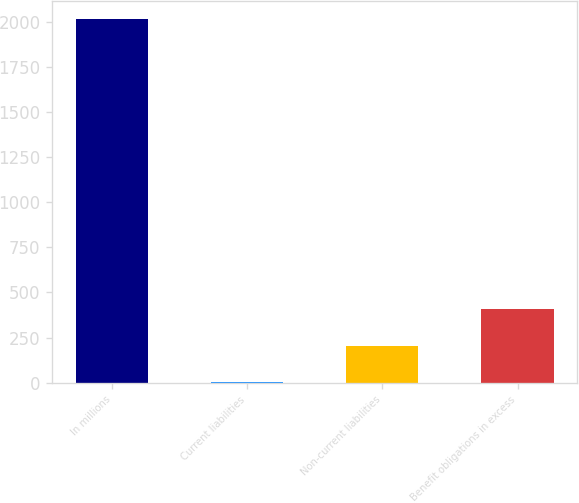Convert chart. <chart><loc_0><loc_0><loc_500><loc_500><bar_chart><fcel>In millions<fcel>Current liabilities<fcel>Non-current liabilities<fcel>Benefit obligations in excess<nl><fcel>2015<fcel>4.1<fcel>205.19<fcel>406.28<nl></chart> 